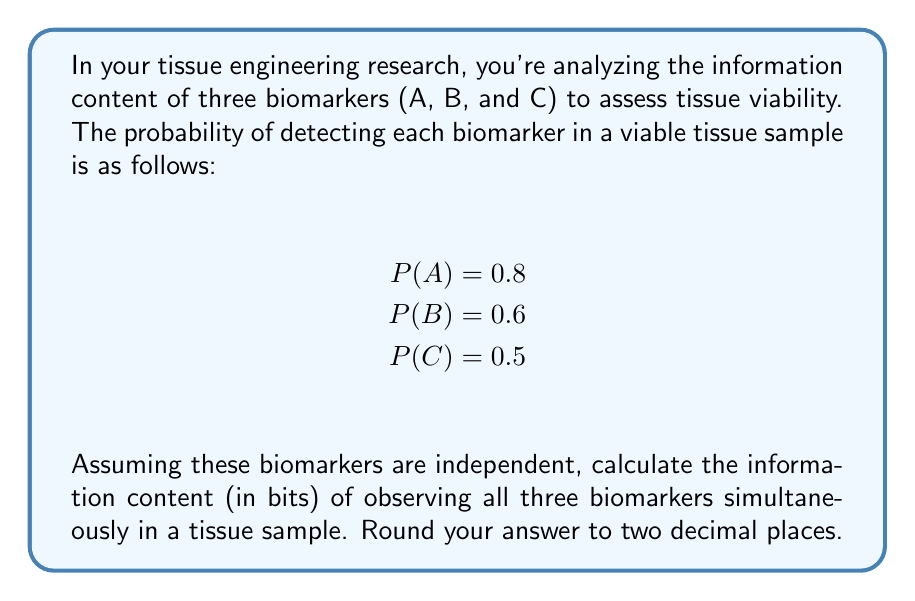What is the answer to this math problem? To solve this problem, we'll use concepts from information theory. The information content of an event is measured in bits and is calculated using the formula:

$$ I(x) = -\log_2(P(x)) $$

where $I(x)$ is the information content and $P(x)$ is the probability of the event occurring.

For independent events, the probability of all events occurring simultaneously is the product of their individual probabilities. So, the probability of observing all three biomarkers (A, B, and C) simultaneously is:

$$ P(A \cap B \cap C) = P(A) \times P(B) \times P(C) $$

Let's calculate this:

$$ P(A \cap B \cap C) = 0.8 \times 0.6 \times 0.5 = 0.24 $$

Now, we can calculate the information content of observing all three biomarks simultaneously:

$$ I(A \cap B \cap C) = -\log_2(P(A \cap B \cap C)) $$
$$ I(A \cap B \cap C) = -\log_2(0.24) $$

Using a calculator or logarithm properties:

$$ I(A \cap B \cap C) = -(-2.0614) = 2.0614 \text{ bits} $$

Rounding to two decimal places gives us 2.06 bits.
Answer: 2.06 bits 